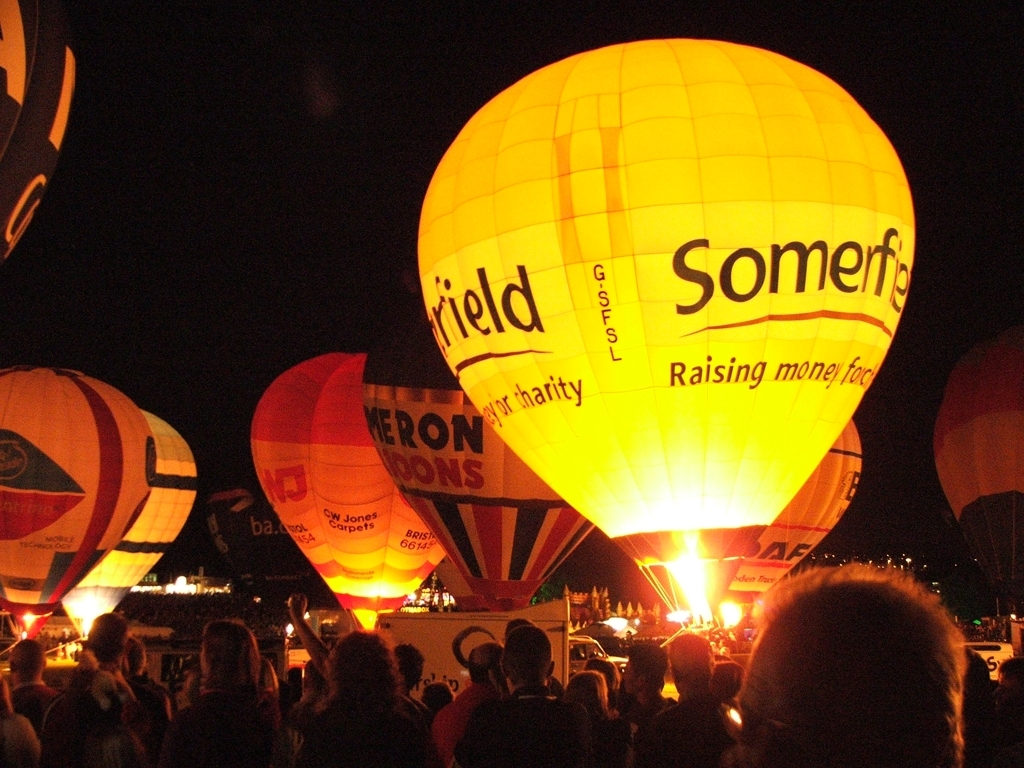How are these balloons illuminating so brightly in the night? The balloons are illuminated from the inside by the powerful burners used to heat the air that causes hot air balloons to rise. During such night-time events, pilots ignite these burners in a coordinated fashion, creating a beautiful glow that outlines the shape and designs of the balloons. 